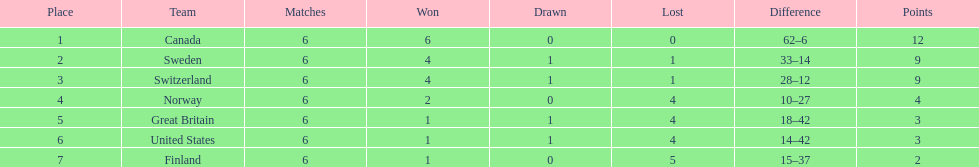How many teams won at least 2 games throughout the 1951 world ice hockey championships? 4. 